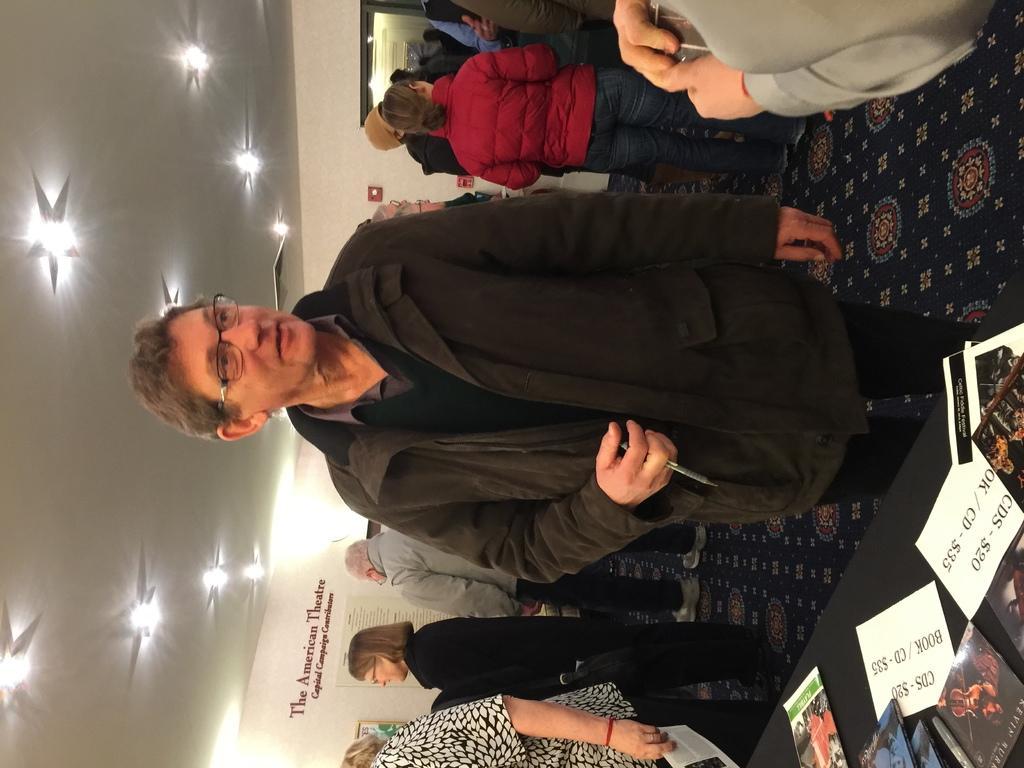In one or two sentences, can you explain what this image depicts? In this image we can see a few people standing, among them some are holding the objects, we can see some objects like books, papers on the table, at the top of the roof, we can see some lights and on the wall we can see some text and photo frame. 